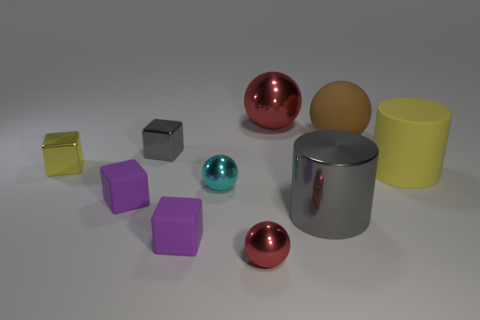What shape is the metal thing that is the same color as the large rubber cylinder?
Provide a succinct answer. Cube. What size is the cube that is in front of the gray metal object to the right of the red metallic sphere in front of the big yellow cylinder?
Provide a short and direct response. Small. There is a cyan thing that is made of the same material as the big gray thing; what size is it?
Make the answer very short. Small. Is there anything else of the same color as the big metal ball?
Ensure brevity in your answer.  Yes. What material is the red thing that is in front of the gray metal thing that is in front of the yellow thing that is behind the large yellow cylinder?
Keep it short and to the point. Metal. How many rubber things are either purple blocks or large gray cylinders?
Provide a succinct answer. 2. What number of things are either tiny cyan shiny spheres or large metal spheres to the left of the yellow cylinder?
Keep it short and to the point. 2. There is a red metal ball behind the gray cylinder; is its size the same as the cyan shiny sphere?
Your answer should be very brief. No. How many other objects are there of the same shape as the yellow matte object?
Offer a very short reply. 1. What number of red things are large metallic cylinders or shiny objects?
Provide a succinct answer. 2. 